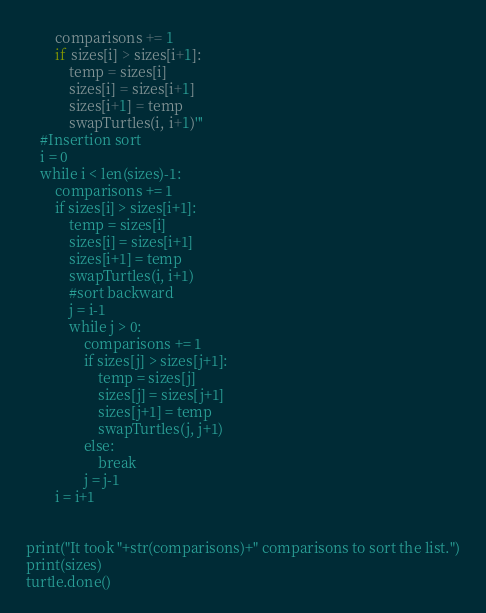<code> <loc_0><loc_0><loc_500><loc_500><_Python_>        comparisons += 1
        if sizes[i] > sizes[i+1]:
            temp = sizes[i]
            sizes[i] = sizes[i+1]
            sizes[i+1] = temp
            swapTurtles(i, i+1)'''
    #Insertion sort
    i = 0
    while i < len(sizes)-1:
        comparisons += 1
        if sizes[i] > sizes[i+1]:
            temp = sizes[i]
            sizes[i] = sizes[i+1]
            sizes[i+1] = temp
            swapTurtles(i, i+1)
            #sort backward
            j = i-1
            while j > 0:
                comparisons += 1
                if sizes[j] > sizes[j+1]:
                    temp = sizes[j]
                    sizes[j] = sizes[j+1]
                    sizes[j+1] = temp
                    swapTurtles(j, j+1)
                else:
                    break
                j = j-1
        i = i+1


print("It took "+str(comparisons)+" comparisons to sort the list.")
print(sizes)
turtle.done()</code> 